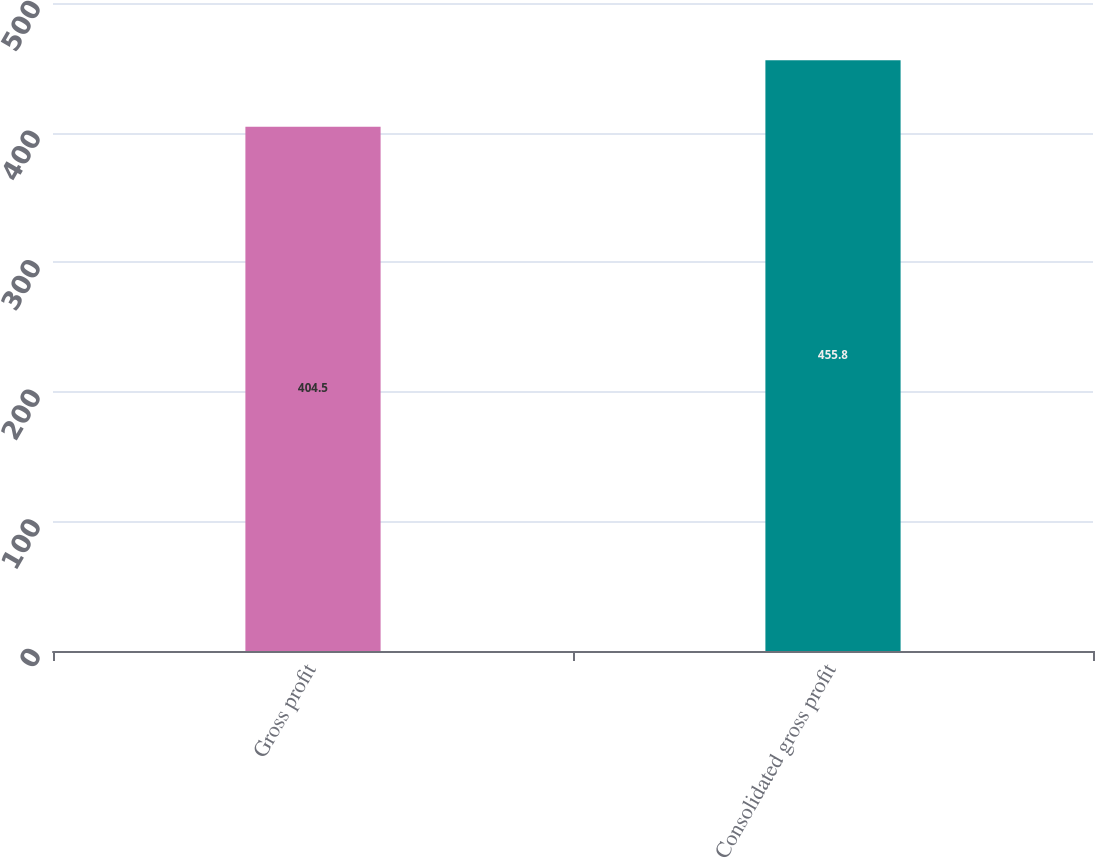<chart> <loc_0><loc_0><loc_500><loc_500><bar_chart><fcel>Gross profit<fcel>Consolidated gross profit<nl><fcel>404.5<fcel>455.8<nl></chart> 